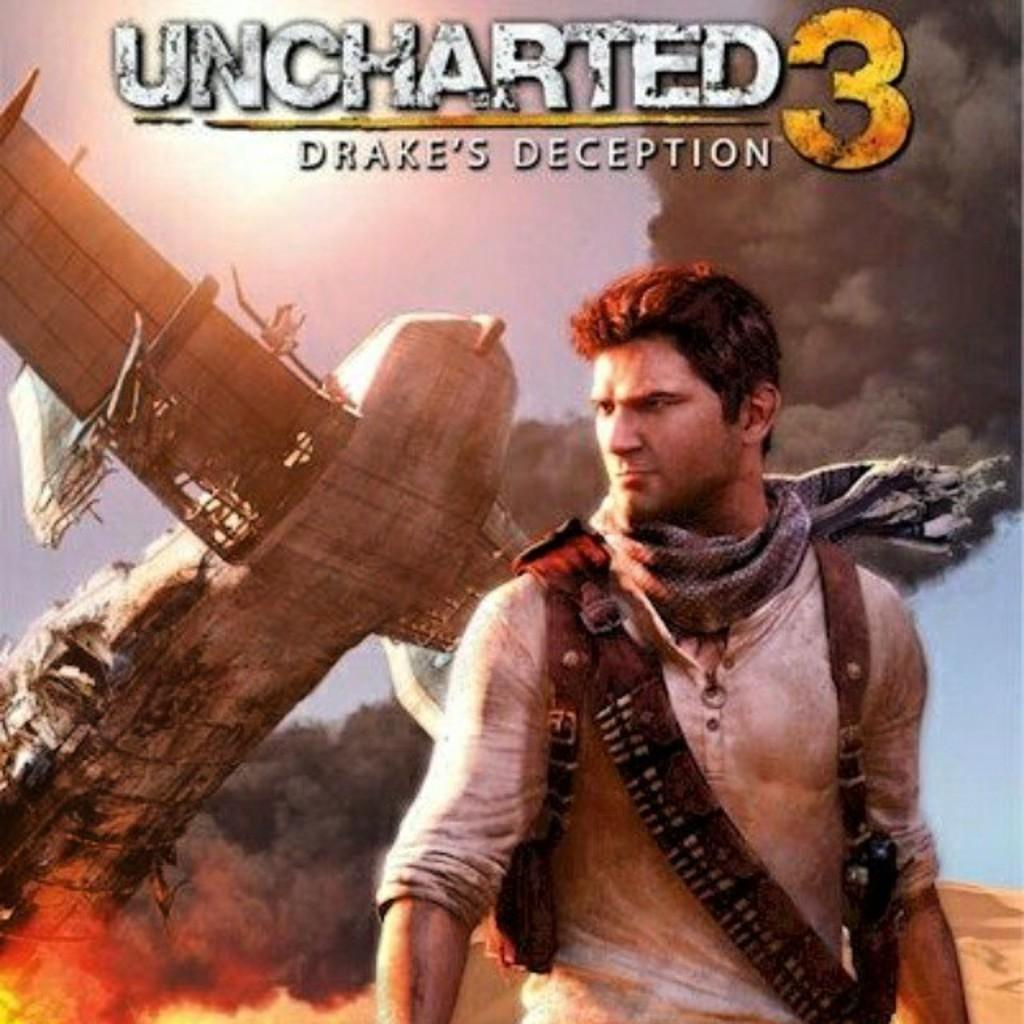<image>
Provide a brief description of the given image. A man wearing a scarf on the cover of Uncharted 3. 